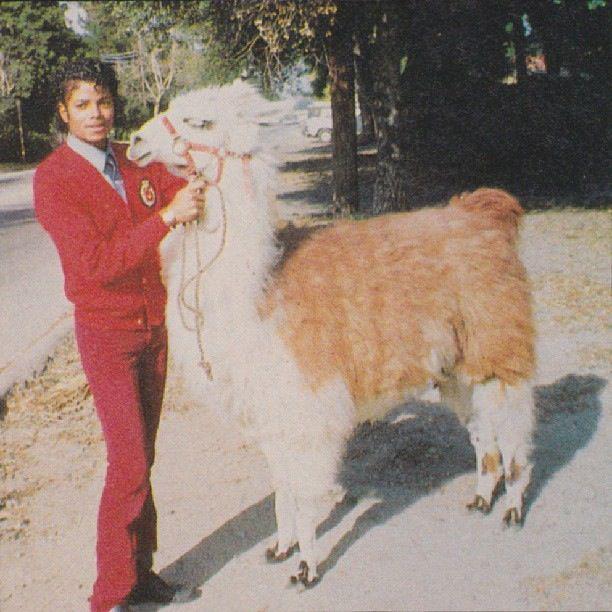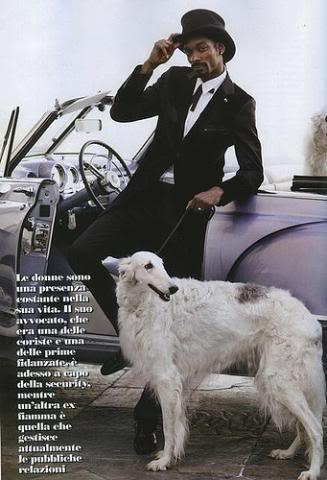The first image is the image on the left, the second image is the image on the right. For the images shown, is this caption "At least three white dogs are shown." true? Answer yes or no. No. The first image is the image on the left, the second image is the image on the right. Evaluate the accuracy of this statement regarding the images: "There are more than two dogs.". Is it true? Answer yes or no. No. 